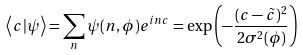Convert formula to latex. <formula><loc_0><loc_0><loc_500><loc_500>\left \langle c | \psi \right \rangle = \sum _ { n } \psi ( n , \phi ) e ^ { i n c } = \exp \left ( - \frac { ( c - \tilde { c } ) ^ { 2 } } { 2 \sigma ^ { 2 } ( \phi ) } \right )</formula> 